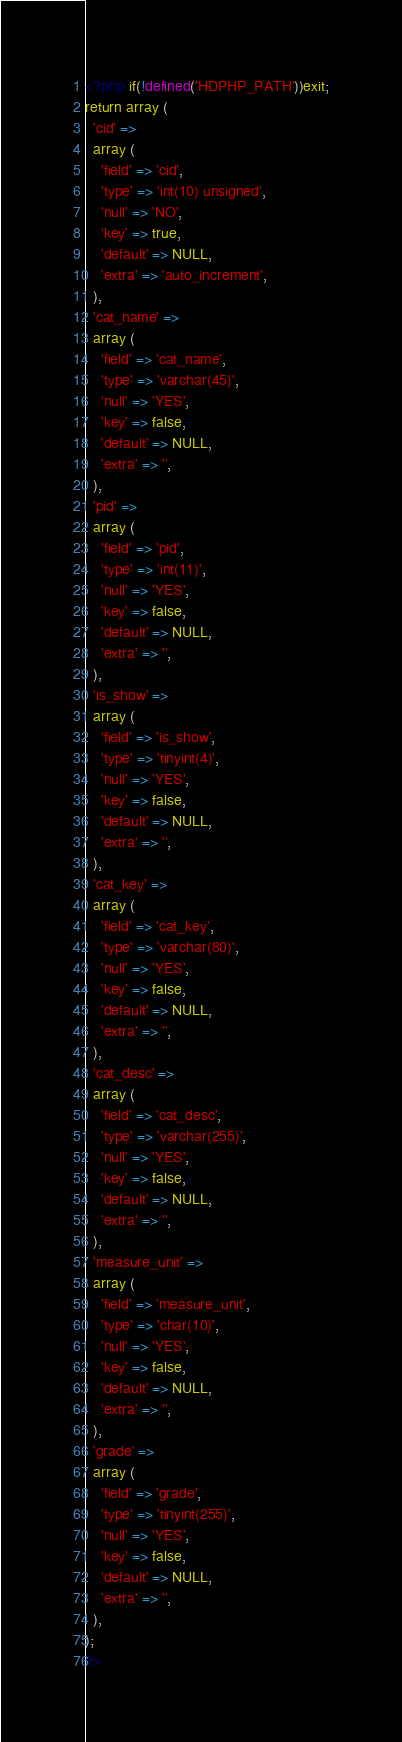Convert code to text. <code><loc_0><loc_0><loc_500><loc_500><_PHP_><?php if(!defined('HDPHP_PATH'))exit;
return array (
  'cid' => 
  array (
    'field' => 'cid',
    'type' => 'int(10) unsigned',
    'null' => 'NO',
    'key' => true,
    'default' => NULL,
    'extra' => 'auto_increment',
  ),
  'cat_name' => 
  array (
    'field' => 'cat_name',
    'type' => 'varchar(45)',
    'null' => 'YES',
    'key' => false,
    'default' => NULL,
    'extra' => '',
  ),
  'pid' => 
  array (
    'field' => 'pid',
    'type' => 'int(11)',
    'null' => 'YES',
    'key' => false,
    'default' => NULL,
    'extra' => '',
  ),
  'is_show' => 
  array (
    'field' => 'is_show',
    'type' => 'tinyint(4)',
    'null' => 'YES',
    'key' => false,
    'default' => NULL,
    'extra' => '',
  ),
  'cat_key' => 
  array (
    'field' => 'cat_key',
    'type' => 'varchar(80)',
    'null' => 'YES',
    'key' => false,
    'default' => NULL,
    'extra' => '',
  ),
  'cat_desc' => 
  array (
    'field' => 'cat_desc',
    'type' => 'varchar(255)',
    'null' => 'YES',
    'key' => false,
    'default' => NULL,
    'extra' => '',
  ),
  'measure_unit' => 
  array (
    'field' => 'measure_unit',
    'type' => 'char(10)',
    'null' => 'YES',
    'key' => false,
    'default' => NULL,
    'extra' => '',
  ),
  'grade' => 
  array (
    'field' => 'grade',
    'type' => 'tinyint(255)',
    'null' => 'YES',
    'key' => false,
    'default' => NULL,
    'extra' => '',
  ),
);
?></code> 